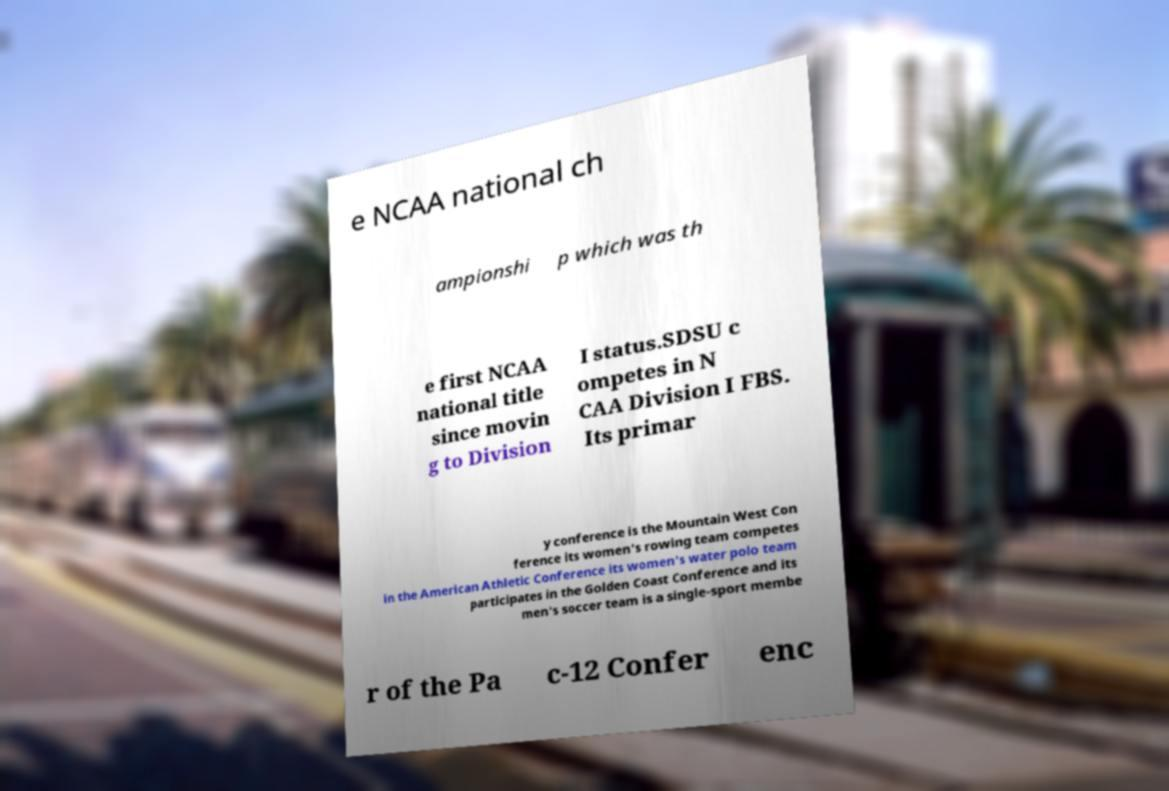Could you assist in decoding the text presented in this image and type it out clearly? e NCAA national ch ampionshi p which was th e first NCAA national title since movin g to Division I status.SDSU c ompetes in N CAA Division I FBS. Its primar y conference is the Mountain West Con ference its women's rowing team competes in the American Athletic Conference its women's water polo team participates in the Golden Coast Conference and its men's soccer team is a single-sport membe r of the Pa c-12 Confer enc 